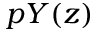<formula> <loc_0><loc_0><loc_500><loc_500>p Y ( z )</formula> 